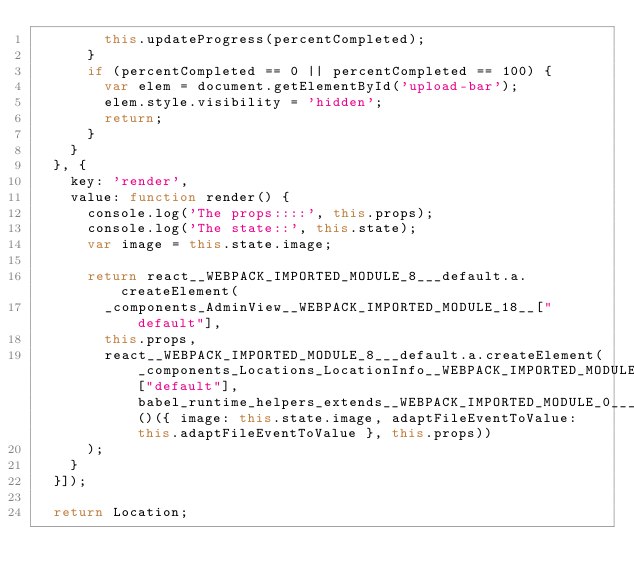Convert code to text. <code><loc_0><loc_0><loc_500><loc_500><_JavaScript_>        this.updateProgress(percentCompleted);
      }
      if (percentCompleted == 0 || percentCompleted == 100) {
        var elem = document.getElementById('upload-bar');
        elem.style.visibility = 'hidden';
        return;
      }
    }
  }, {
    key: 'render',
    value: function render() {
      console.log('The props::::', this.props);
      console.log('The state::', this.state);
      var image = this.state.image;

      return react__WEBPACK_IMPORTED_MODULE_8___default.a.createElement(
        _components_AdminView__WEBPACK_IMPORTED_MODULE_18__["default"],
        this.props,
        react__WEBPACK_IMPORTED_MODULE_8___default.a.createElement(_components_Locations_LocationInfo__WEBPACK_IMPORTED_MODULE_17__["default"], babel_runtime_helpers_extends__WEBPACK_IMPORTED_MODULE_0___default()({ image: this.state.image, adaptFileEventToValue: this.adaptFileEventToValue }, this.props))
      );
    }
  }]);

  return Location;</code> 